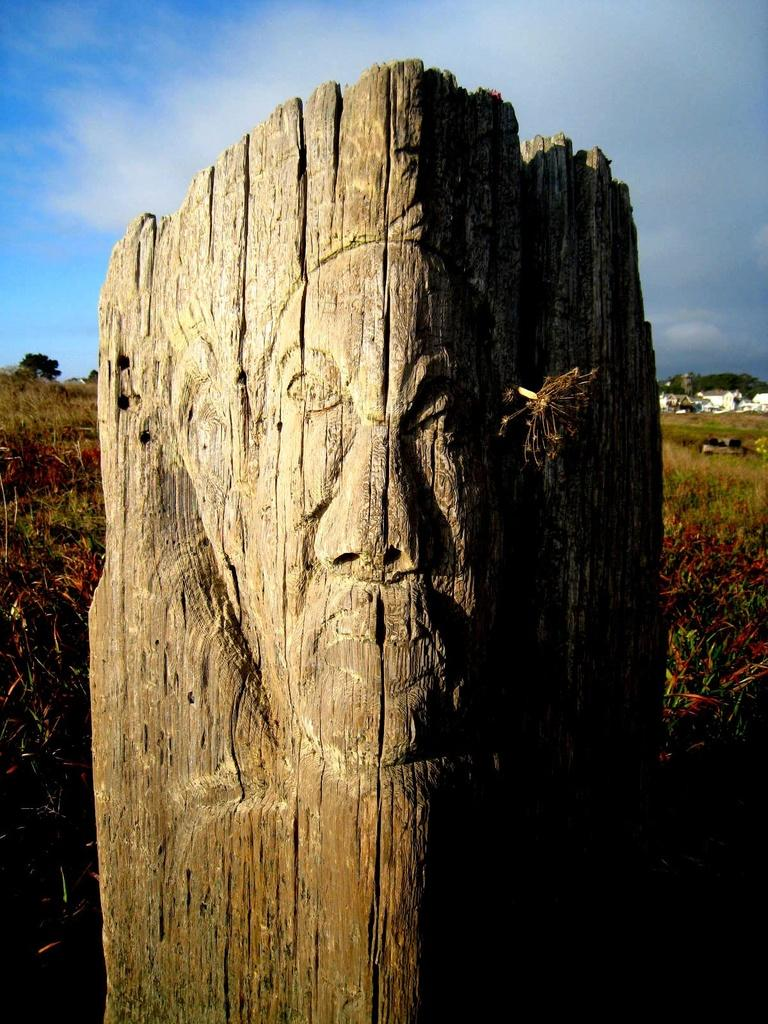What type of art is depicted in the image? The image is a wood carving. What can be seen in the background of the wood carving? There is grass in the background of the image. What is the weather like in the image? The sky is cloudy in the image. What type of rabbit is attracting the governor's attention in the image? There is no rabbit or governor present in the image; it is a wood carving with grass in the background and a cloudy sky. 